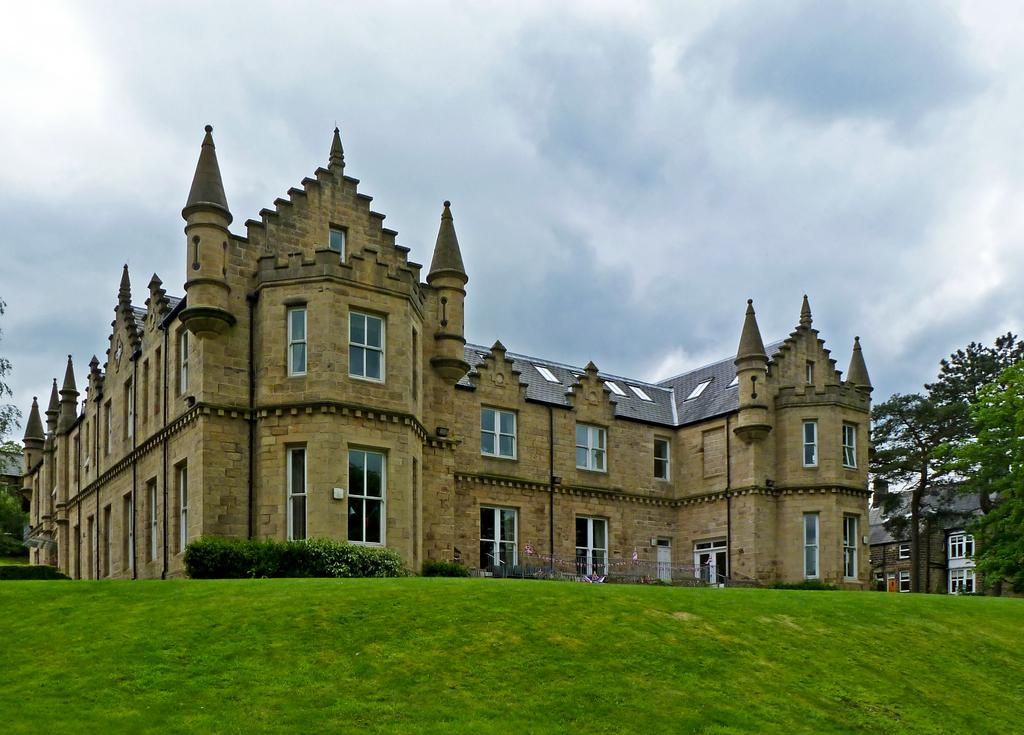What type of vegetation can be seen in the image? There is grass, plants, and trees in the image. What type of structures are present in the image? There are buildings in the image. What else can be seen in the image besides vegetation and structures? There are objects in the image. What is visible in the background of the image? The sky is visible in the background of the image. What can be observed in the sky? Clouds are present in the sky. Where is the net located in the image? There is no net present in the image. What type of range can be seen in the image? There is no range present in the image. 